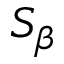Convert formula to latex. <formula><loc_0><loc_0><loc_500><loc_500>S _ { \beta }</formula> 